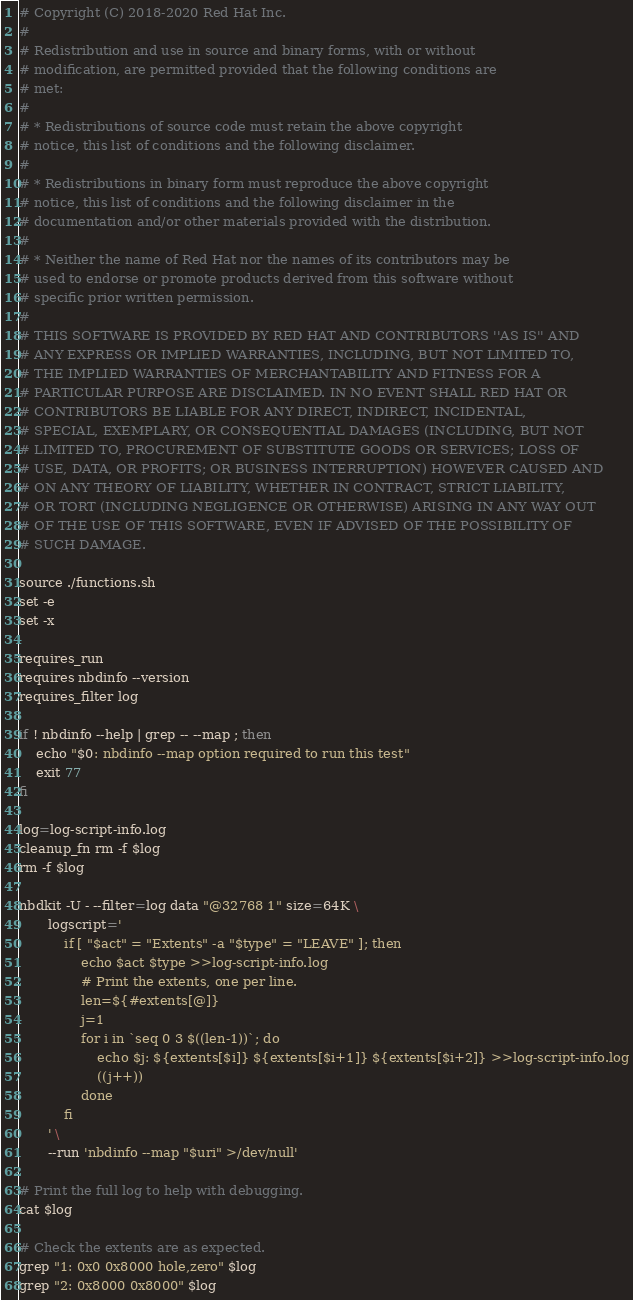<code> <loc_0><loc_0><loc_500><loc_500><_Bash_># Copyright (C) 2018-2020 Red Hat Inc.
#
# Redistribution and use in source and binary forms, with or without
# modification, are permitted provided that the following conditions are
# met:
#
# * Redistributions of source code must retain the above copyright
# notice, this list of conditions and the following disclaimer.
#
# * Redistributions in binary form must reproduce the above copyright
# notice, this list of conditions and the following disclaimer in the
# documentation and/or other materials provided with the distribution.
#
# * Neither the name of Red Hat nor the names of its contributors may be
# used to endorse or promote products derived from this software without
# specific prior written permission.
#
# THIS SOFTWARE IS PROVIDED BY RED HAT AND CONTRIBUTORS ''AS IS'' AND
# ANY EXPRESS OR IMPLIED WARRANTIES, INCLUDING, BUT NOT LIMITED TO,
# THE IMPLIED WARRANTIES OF MERCHANTABILITY AND FITNESS FOR A
# PARTICULAR PURPOSE ARE DISCLAIMED. IN NO EVENT SHALL RED HAT OR
# CONTRIBUTORS BE LIABLE FOR ANY DIRECT, INDIRECT, INCIDENTAL,
# SPECIAL, EXEMPLARY, OR CONSEQUENTIAL DAMAGES (INCLUDING, BUT NOT
# LIMITED TO, PROCUREMENT OF SUBSTITUTE GOODS OR SERVICES; LOSS OF
# USE, DATA, OR PROFITS; OR BUSINESS INTERRUPTION) HOWEVER CAUSED AND
# ON ANY THEORY OF LIABILITY, WHETHER IN CONTRACT, STRICT LIABILITY,
# OR TORT (INCLUDING NEGLIGENCE OR OTHERWISE) ARISING IN ANY WAY OUT
# OF THE USE OF THIS SOFTWARE, EVEN IF ADVISED OF THE POSSIBILITY OF
# SUCH DAMAGE.

source ./functions.sh
set -e
set -x

requires_run
requires nbdinfo --version
requires_filter log

if ! nbdinfo --help | grep -- --map ; then
    echo "$0: nbdinfo --map option required to run this test"
    exit 77
fi

log=log-script-info.log
cleanup_fn rm -f $log
rm -f $log

nbdkit -U - --filter=log data "@32768 1" size=64K \
       logscript='
           if [ "$act" = "Extents" -a "$type" = "LEAVE" ]; then
               echo $act $type >>log-script-info.log
               # Print the extents, one per line.
               len=${#extents[@]}
               j=1
               for i in `seq 0 3 $((len-1))`; do
                   echo $j: ${extents[$i]} ${extents[$i+1]} ${extents[$i+2]} >>log-script-info.log
                   ((j++))
               done
           fi
       ' \
       --run 'nbdinfo --map "$uri" >/dev/null'

# Print the full log to help with debugging.
cat $log

# Check the extents are as expected.
grep "1: 0x0 0x8000 hole,zero" $log
grep "2: 0x8000 0x8000" $log
</code> 